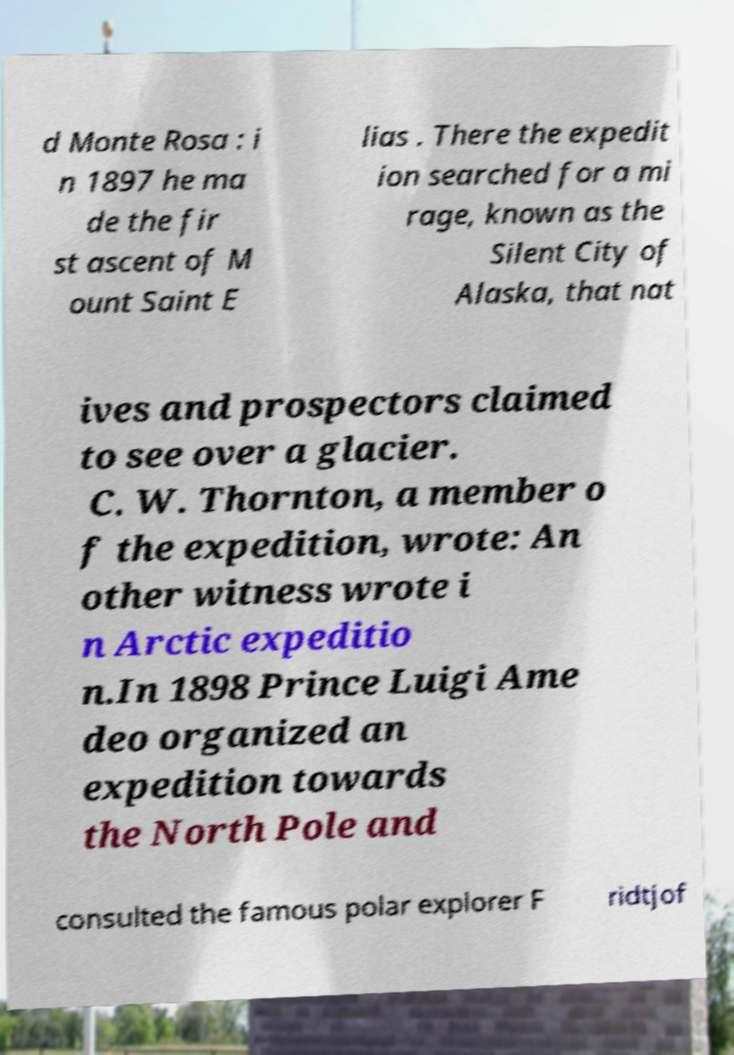I need the written content from this picture converted into text. Can you do that? d Monte Rosa : i n 1897 he ma de the fir st ascent of M ount Saint E lias . There the expedit ion searched for a mi rage, known as the Silent City of Alaska, that nat ives and prospectors claimed to see over a glacier. C. W. Thornton, a member o f the expedition, wrote: An other witness wrote i n Arctic expeditio n.In 1898 Prince Luigi Ame deo organized an expedition towards the North Pole and consulted the famous polar explorer F ridtjof 